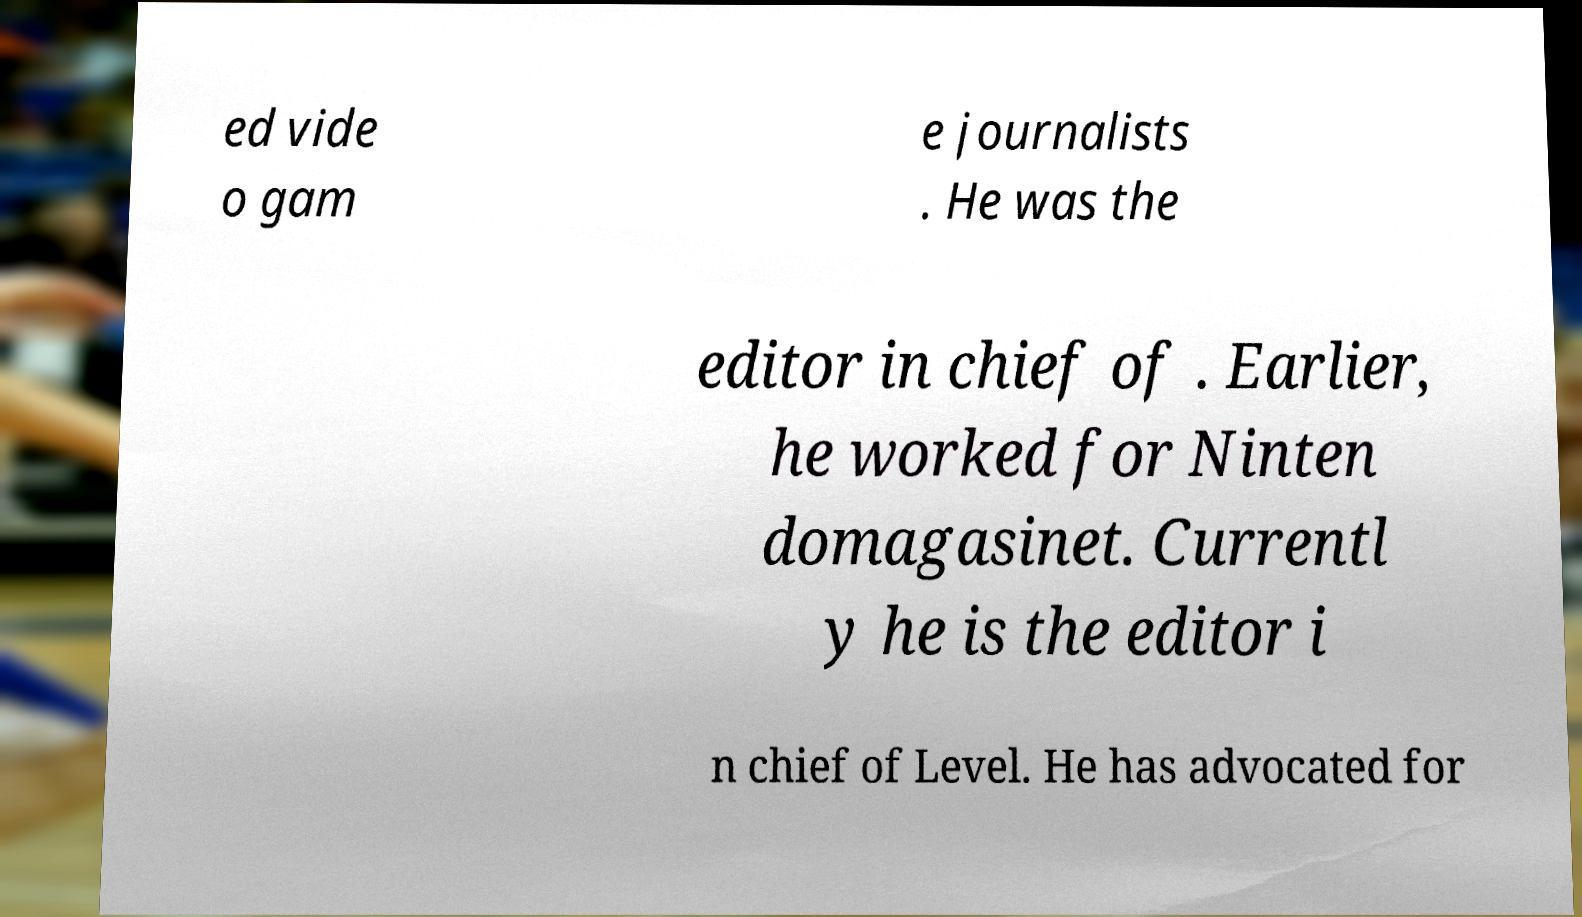Can you read and provide the text displayed in the image?This photo seems to have some interesting text. Can you extract and type it out for me? ed vide o gam e journalists . He was the editor in chief of . Earlier, he worked for Ninten domagasinet. Currentl y he is the editor i n chief of Level. He has advocated for 